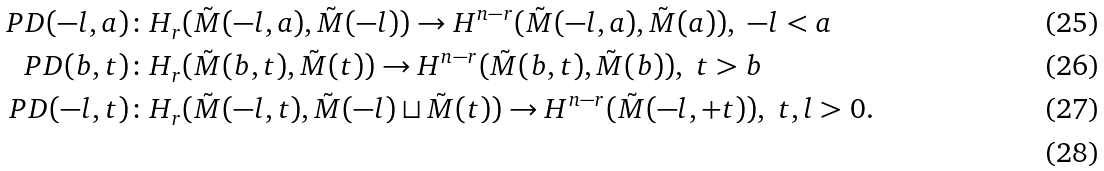Convert formula to latex. <formula><loc_0><loc_0><loc_500><loc_500>P D ( - l , a ) & \colon H _ { r } ( \tilde { M } ( - l , a ) , \tilde { M } ( - l ) ) \to H ^ { n - r } ( \tilde { M } ( - l , a ) , \tilde { M } ( a ) ) , \ - l < a \\ P D ( b , t ) & \colon H _ { r } ( \tilde { M } ( b , t ) , \tilde { M } ( t ) ) \to H ^ { n - r } ( \tilde { M } ( b , t ) , \tilde { M } ( b ) ) , \ t > b \\ P D ( - l , t ) & \colon H _ { r } ( \tilde { M } ( - l , t ) , \tilde { M } ( - l ) \sqcup \tilde { M } ( t ) ) \to H ^ { n - r } ( \tilde { M } ( - l , + t ) ) , \ t , l > 0 . \\</formula> 